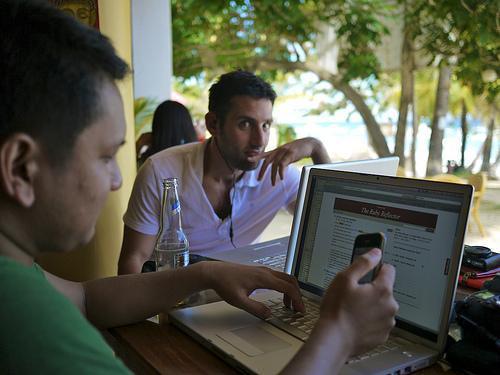How many laptops are in the photo?
Give a very brief answer. 1. 